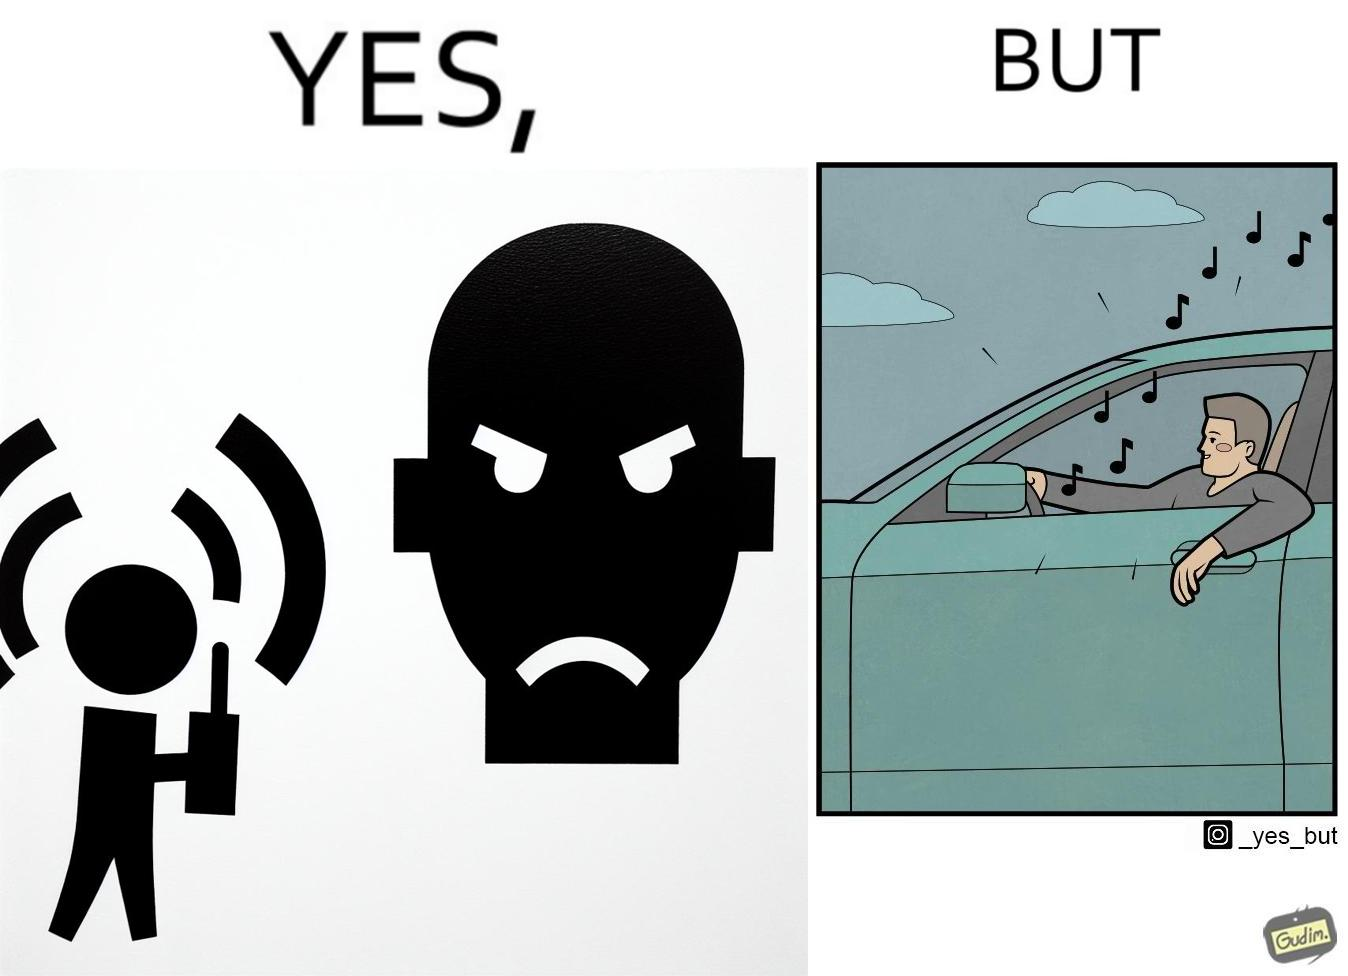Does this image contain satire or humor? Yes, this image is satirical. 